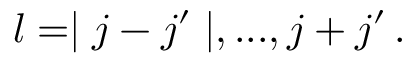<formula> <loc_0><loc_0><loc_500><loc_500>l = | j - j ^ { \prime } | , \dots , j + j ^ { \prime } \, .</formula> 